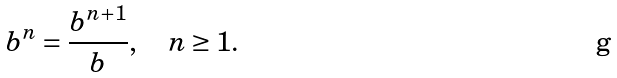<formula> <loc_0><loc_0><loc_500><loc_500>b ^ { n } = { \frac { b ^ { n + 1 } } { b } } , \quad n \geq 1 .</formula> 